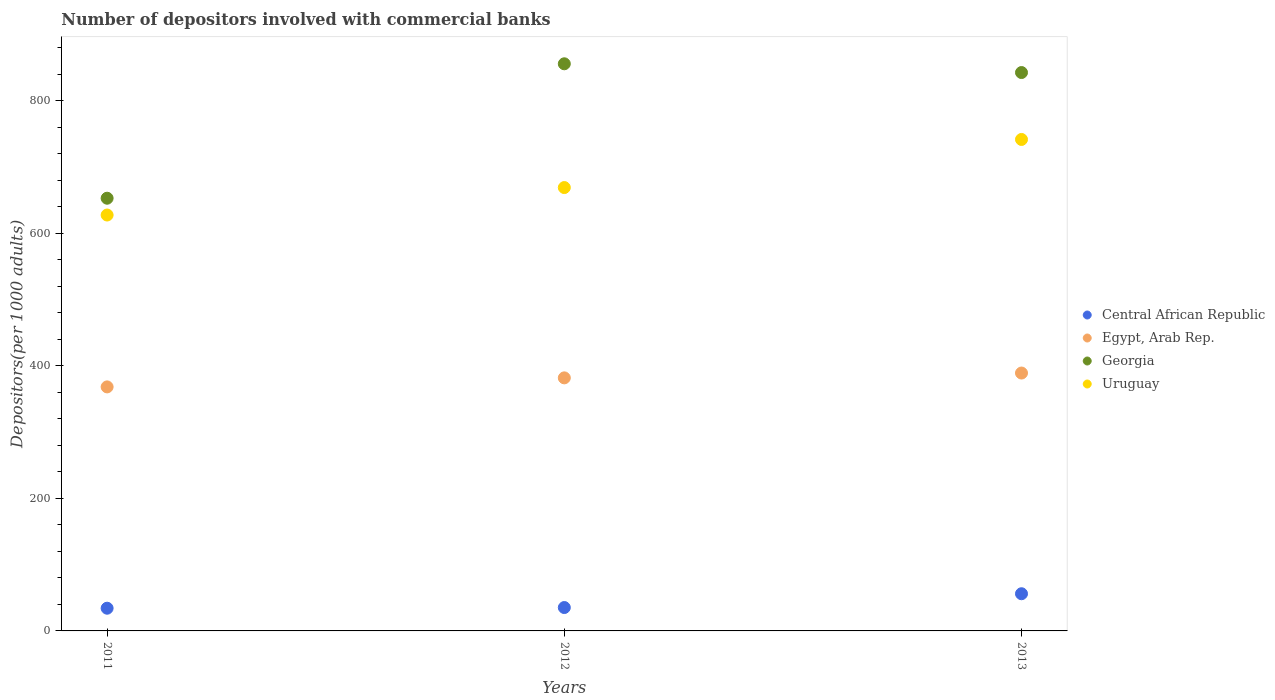How many different coloured dotlines are there?
Offer a very short reply. 4. Is the number of dotlines equal to the number of legend labels?
Your response must be concise. Yes. What is the number of depositors involved with commercial banks in Central African Republic in 2012?
Your answer should be compact. 35.28. Across all years, what is the maximum number of depositors involved with commercial banks in Central African Republic?
Make the answer very short. 56.1. Across all years, what is the minimum number of depositors involved with commercial banks in Egypt, Arab Rep.?
Offer a very short reply. 368.19. In which year was the number of depositors involved with commercial banks in Uruguay maximum?
Your response must be concise. 2013. In which year was the number of depositors involved with commercial banks in Egypt, Arab Rep. minimum?
Provide a succinct answer. 2011. What is the total number of depositors involved with commercial banks in Georgia in the graph?
Make the answer very short. 2351.11. What is the difference between the number of depositors involved with commercial banks in Central African Republic in 2012 and that in 2013?
Your answer should be very brief. -20.82. What is the difference between the number of depositors involved with commercial banks in Georgia in 2011 and the number of depositors involved with commercial banks in Uruguay in 2012?
Your answer should be very brief. -16.08. What is the average number of depositors involved with commercial banks in Uruguay per year?
Your answer should be compact. 679.35. In the year 2012, what is the difference between the number of depositors involved with commercial banks in Egypt, Arab Rep. and number of depositors involved with commercial banks in Georgia?
Offer a very short reply. -473.89. What is the ratio of the number of depositors involved with commercial banks in Uruguay in 2011 to that in 2013?
Provide a short and direct response. 0.85. Is the number of depositors involved with commercial banks in Georgia in 2011 less than that in 2013?
Ensure brevity in your answer.  Yes. Is the difference between the number of depositors involved with commercial banks in Egypt, Arab Rep. in 2011 and 2012 greater than the difference between the number of depositors involved with commercial banks in Georgia in 2011 and 2012?
Ensure brevity in your answer.  Yes. What is the difference between the highest and the second highest number of depositors involved with commercial banks in Georgia?
Your response must be concise. 13.2. What is the difference between the highest and the lowest number of depositors involved with commercial banks in Egypt, Arab Rep.?
Offer a terse response. 20.91. In how many years, is the number of depositors involved with commercial banks in Uruguay greater than the average number of depositors involved with commercial banks in Uruguay taken over all years?
Your answer should be very brief. 1. Is it the case that in every year, the sum of the number of depositors involved with commercial banks in Central African Republic and number of depositors involved with commercial banks in Egypt, Arab Rep.  is greater than the number of depositors involved with commercial banks in Uruguay?
Provide a short and direct response. No. Does the number of depositors involved with commercial banks in Central African Republic monotonically increase over the years?
Keep it short and to the point. Yes. Is the number of depositors involved with commercial banks in Egypt, Arab Rep. strictly greater than the number of depositors involved with commercial banks in Uruguay over the years?
Offer a very short reply. No. How many dotlines are there?
Offer a terse response. 4. What is the difference between two consecutive major ticks on the Y-axis?
Your response must be concise. 200. Are the values on the major ticks of Y-axis written in scientific E-notation?
Offer a terse response. No. Does the graph contain grids?
Give a very brief answer. No. Where does the legend appear in the graph?
Your answer should be very brief. Center right. How many legend labels are there?
Your answer should be very brief. 4. How are the legend labels stacked?
Make the answer very short. Vertical. What is the title of the graph?
Give a very brief answer. Number of depositors involved with commercial banks. Does "Angola" appear as one of the legend labels in the graph?
Your answer should be compact. No. What is the label or title of the Y-axis?
Offer a terse response. Depositors(per 1000 adults). What is the Depositors(per 1000 adults) in Central African Republic in 2011?
Keep it short and to the point. 34.26. What is the Depositors(per 1000 adults) in Egypt, Arab Rep. in 2011?
Offer a very short reply. 368.19. What is the Depositors(per 1000 adults) in Georgia in 2011?
Your response must be concise. 652.89. What is the Depositors(per 1000 adults) in Uruguay in 2011?
Your answer should be very brief. 627.53. What is the Depositors(per 1000 adults) in Central African Republic in 2012?
Provide a succinct answer. 35.28. What is the Depositors(per 1000 adults) in Egypt, Arab Rep. in 2012?
Offer a very short reply. 381.83. What is the Depositors(per 1000 adults) in Georgia in 2012?
Make the answer very short. 855.71. What is the Depositors(per 1000 adults) in Uruguay in 2012?
Your answer should be very brief. 668.96. What is the Depositors(per 1000 adults) of Central African Republic in 2013?
Give a very brief answer. 56.1. What is the Depositors(per 1000 adults) of Egypt, Arab Rep. in 2013?
Provide a succinct answer. 389.11. What is the Depositors(per 1000 adults) of Georgia in 2013?
Your answer should be very brief. 842.51. What is the Depositors(per 1000 adults) in Uruguay in 2013?
Provide a succinct answer. 741.55. Across all years, what is the maximum Depositors(per 1000 adults) in Central African Republic?
Give a very brief answer. 56.1. Across all years, what is the maximum Depositors(per 1000 adults) of Egypt, Arab Rep.?
Offer a very short reply. 389.11. Across all years, what is the maximum Depositors(per 1000 adults) in Georgia?
Ensure brevity in your answer.  855.71. Across all years, what is the maximum Depositors(per 1000 adults) of Uruguay?
Ensure brevity in your answer.  741.55. Across all years, what is the minimum Depositors(per 1000 adults) of Central African Republic?
Your response must be concise. 34.26. Across all years, what is the minimum Depositors(per 1000 adults) in Egypt, Arab Rep.?
Provide a short and direct response. 368.19. Across all years, what is the minimum Depositors(per 1000 adults) in Georgia?
Provide a short and direct response. 652.89. Across all years, what is the minimum Depositors(per 1000 adults) in Uruguay?
Give a very brief answer. 627.53. What is the total Depositors(per 1000 adults) of Central African Republic in the graph?
Make the answer very short. 125.63. What is the total Depositors(per 1000 adults) in Egypt, Arab Rep. in the graph?
Provide a succinct answer. 1139.13. What is the total Depositors(per 1000 adults) in Georgia in the graph?
Offer a terse response. 2351.11. What is the total Depositors(per 1000 adults) in Uruguay in the graph?
Make the answer very short. 2038.04. What is the difference between the Depositors(per 1000 adults) of Central African Republic in 2011 and that in 2012?
Offer a very short reply. -1.02. What is the difference between the Depositors(per 1000 adults) in Egypt, Arab Rep. in 2011 and that in 2012?
Your answer should be very brief. -13.63. What is the difference between the Depositors(per 1000 adults) in Georgia in 2011 and that in 2012?
Ensure brevity in your answer.  -202.83. What is the difference between the Depositors(per 1000 adults) in Uruguay in 2011 and that in 2012?
Ensure brevity in your answer.  -41.43. What is the difference between the Depositors(per 1000 adults) of Central African Republic in 2011 and that in 2013?
Provide a short and direct response. -21.84. What is the difference between the Depositors(per 1000 adults) of Egypt, Arab Rep. in 2011 and that in 2013?
Make the answer very short. -20.91. What is the difference between the Depositors(per 1000 adults) in Georgia in 2011 and that in 2013?
Your response must be concise. -189.63. What is the difference between the Depositors(per 1000 adults) of Uruguay in 2011 and that in 2013?
Your response must be concise. -114.02. What is the difference between the Depositors(per 1000 adults) of Central African Republic in 2012 and that in 2013?
Provide a succinct answer. -20.82. What is the difference between the Depositors(per 1000 adults) of Egypt, Arab Rep. in 2012 and that in 2013?
Your answer should be very brief. -7.28. What is the difference between the Depositors(per 1000 adults) of Georgia in 2012 and that in 2013?
Offer a very short reply. 13.2. What is the difference between the Depositors(per 1000 adults) in Uruguay in 2012 and that in 2013?
Your answer should be very brief. -72.59. What is the difference between the Depositors(per 1000 adults) in Central African Republic in 2011 and the Depositors(per 1000 adults) in Egypt, Arab Rep. in 2012?
Give a very brief answer. -347.57. What is the difference between the Depositors(per 1000 adults) in Central African Republic in 2011 and the Depositors(per 1000 adults) in Georgia in 2012?
Provide a succinct answer. -821.46. What is the difference between the Depositors(per 1000 adults) of Central African Republic in 2011 and the Depositors(per 1000 adults) of Uruguay in 2012?
Provide a short and direct response. -634.71. What is the difference between the Depositors(per 1000 adults) in Egypt, Arab Rep. in 2011 and the Depositors(per 1000 adults) in Georgia in 2012?
Your answer should be very brief. -487.52. What is the difference between the Depositors(per 1000 adults) of Egypt, Arab Rep. in 2011 and the Depositors(per 1000 adults) of Uruguay in 2012?
Provide a succinct answer. -300.77. What is the difference between the Depositors(per 1000 adults) in Georgia in 2011 and the Depositors(per 1000 adults) in Uruguay in 2012?
Ensure brevity in your answer.  -16.08. What is the difference between the Depositors(per 1000 adults) in Central African Republic in 2011 and the Depositors(per 1000 adults) in Egypt, Arab Rep. in 2013?
Offer a terse response. -354.85. What is the difference between the Depositors(per 1000 adults) of Central African Republic in 2011 and the Depositors(per 1000 adults) of Georgia in 2013?
Offer a very short reply. -808.26. What is the difference between the Depositors(per 1000 adults) of Central African Republic in 2011 and the Depositors(per 1000 adults) of Uruguay in 2013?
Ensure brevity in your answer.  -707.29. What is the difference between the Depositors(per 1000 adults) of Egypt, Arab Rep. in 2011 and the Depositors(per 1000 adults) of Georgia in 2013?
Your response must be concise. -474.32. What is the difference between the Depositors(per 1000 adults) in Egypt, Arab Rep. in 2011 and the Depositors(per 1000 adults) in Uruguay in 2013?
Provide a succinct answer. -373.36. What is the difference between the Depositors(per 1000 adults) in Georgia in 2011 and the Depositors(per 1000 adults) in Uruguay in 2013?
Offer a very short reply. -88.66. What is the difference between the Depositors(per 1000 adults) of Central African Republic in 2012 and the Depositors(per 1000 adults) of Egypt, Arab Rep. in 2013?
Ensure brevity in your answer.  -353.83. What is the difference between the Depositors(per 1000 adults) of Central African Republic in 2012 and the Depositors(per 1000 adults) of Georgia in 2013?
Ensure brevity in your answer.  -807.23. What is the difference between the Depositors(per 1000 adults) in Central African Republic in 2012 and the Depositors(per 1000 adults) in Uruguay in 2013?
Make the answer very short. -706.27. What is the difference between the Depositors(per 1000 adults) of Egypt, Arab Rep. in 2012 and the Depositors(per 1000 adults) of Georgia in 2013?
Give a very brief answer. -460.68. What is the difference between the Depositors(per 1000 adults) in Egypt, Arab Rep. in 2012 and the Depositors(per 1000 adults) in Uruguay in 2013?
Provide a short and direct response. -359.72. What is the difference between the Depositors(per 1000 adults) of Georgia in 2012 and the Depositors(per 1000 adults) of Uruguay in 2013?
Provide a succinct answer. 114.17. What is the average Depositors(per 1000 adults) of Central African Republic per year?
Make the answer very short. 41.88. What is the average Depositors(per 1000 adults) of Egypt, Arab Rep. per year?
Offer a terse response. 379.71. What is the average Depositors(per 1000 adults) in Georgia per year?
Offer a terse response. 783.7. What is the average Depositors(per 1000 adults) of Uruguay per year?
Ensure brevity in your answer.  679.35. In the year 2011, what is the difference between the Depositors(per 1000 adults) of Central African Republic and Depositors(per 1000 adults) of Egypt, Arab Rep.?
Your answer should be very brief. -333.94. In the year 2011, what is the difference between the Depositors(per 1000 adults) in Central African Republic and Depositors(per 1000 adults) in Georgia?
Provide a succinct answer. -618.63. In the year 2011, what is the difference between the Depositors(per 1000 adults) of Central African Republic and Depositors(per 1000 adults) of Uruguay?
Offer a very short reply. -593.28. In the year 2011, what is the difference between the Depositors(per 1000 adults) of Egypt, Arab Rep. and Depositors(per 1000 adults) of Georgia?
Make the answer very short. -284.69. In the year 2011, what is the difference between the Depositors(per 1000 adults) in Egypt, Arab Rep. and Depositors(per 1000 adults) in Uruguay?
Provide a succinct answer. -259.34. In the year 2011, what is the difference between the Depositors(per 1000 adults) in Georgia and Depositors(per 1000 adults) in Uruguay?
Offer a terse response. 25.36. In the year 2012, what is the difference between the Depositors(per 1000 adults) of Central African Republic and Depositors(per 1000 adults) of Egypt, Arab Rep.?
Your answer should be very brief. -346.55. In the year 2012, what is the difference between the Depositors(per 1000 adults) in Central African Republic and Depositors(per 1000 adults) in Georgia?
Give a very brief answer. -820.43. In the year 2012, what is the difference between the Depositors(per 1000 adults) in Central African Republic and Depositors(per 1000 adults) in Uruguay?
Provide a short and direct response. -633.68. In the year 2012, what is the difference between the Depositors(per 1000 adults) in Egypt, Arab Rep. and Depositors(per 1000 adults) in Georgia?
Provide a short and direct response. -473.89. In the year 2012, what is the difference between the Depositors(per 1000 adults) of Egypt, Arab Rep. and Depositors(per 1000 adults) of Uruguay?
Give a very brief answer. -287.13. In the year 2012, what is the difference between the Depositors(per 1000 adults) in Georgia and Depositors(per 1000 adults) in Uruguay?
Your response must be concise. 186.75. In the year 2013, what is the difference between the Depositors(per 1000 adults) of Central African Republic and Depositors(per 1000 adults) of Egypt, Arab Rep.?
Make the answer very short. -333.01. In the year 2013, what is the difference between the Depositors(per 1000 adults) in Central African Republic and Depositors(per 1000 adults) in Georgia?
Your answer should be compact. -786.41. In the year 2013, what is the difference between the Depositors(per 1000 adults) in Central African Republic and Depositors(per 1000 adults) in Uruguay?
Keep it short and to the point. -685.45. In the year 2013, what is the difference between the Depositors(per 1000 adults) of Egypt, Arab Rep. and Depositors(per 1000 adults) of Georgia?
Give a very brief answer. -453.41. In the year 2013, what is the difference between the Depositors(per 1000 adults) in Egypt, Arab Rep. and Depositors(per 1000 adults) in Uruguay?
Provide a short and direct response. -352.44. In the year 2013, what is the difference between the Depositors(per 1000 adults) of Georgia and Depositors(per 1000 adults) of Uruguay?
Provide a succinct answer. 100.96. What is the ratio of the Depositors(per 1000 adults) of Central African Republic in 2011 to that in 2012?
Provide a succinct answer. 0.97. What is the ratio of the Depositors(per 1000 adults) of Egypt, Arab Rep. in 2011 to that in 2012?
Offer a very short reply. 0.96. What is the ratio of the Depositors(per 1000 adults) of Georgia in 2011 to that in 2012?
Your answer should be compact. 0.76. What is the ratio of the Depositors(per 1000 adults) in Uruguay in 2011 to that in 2012?
Your answer should be compact. 0.94. What is the ratio of the Depositors(per 1000 adults) in Central African Republic in 2011 to that in 2013?
Your answer should be very brief. 0.61. What is the ratio of the Depositors(per 1000 adults) in Egypt, Arab Rep. in 2011 to that in 2013?
Your answer should be very brief. 0.95. What is the ratio of the Depositors(per 1000 adults) in Georgia in 2011 to that in 2013?
Your answer should be very brief. 0.77. What is the ratio of the Depositors(per 1000 adults) of Uruguay in 2011 to that in 2013?
Offer a terse response. 0.85. What is the ratio of the Depositors(per 1000 adults) of Central African Republic in 2012 to that in 2013?
Keep it short and to the point. 0.63. What is the ratio of the Depositors(per 1000 adults) in Egypt, Arab Rep. in 2012 to that in 2013?
Provide a succinct answer. 0.98. What is the ratio of the Depositors(per 1000 adults) in Georgia in 2012 to that in 2013?
Your response must be concise. 1.02. What is the ratio of the Depositors(per 1000 adults) in Uruguay in 2012 to that in 2013?
Give a very brief answer. 0.9. What is the difference between the highest and the second highest Depositors(per 1000 adults) of Central African Republic?
Ensure brevity in your answer.  20.82. What is the difference between the highest and the second highest Depositors(per 1000 adults) of Egypt, Arab Rep.?
Provide a short and direct response. 7.28. What is the difference between the highest and the second highest Depositors(per 1000 adults) of Georgia?
Make the answer very short. 13.2. What is the difference between the highest and the second highest Depositors(per 1000 adults) in Uruguay?
Your response must be concise. 72.59. What is the difference between the highest and the lowest Depositors(per 1000 adults) in Central African Republic?
Your answer should be compact. 21.84. What is the difference between the highest and the lowest Depositors(per 1000 adults) in Egypt, Arab Rep.?
Keep it short and to the point. 20.91. What is the difference between the highest and the lowest Depositors(per 1000 adults) of Georgia?
Ensure brevity in your answer.  202.83. What is the difference between the highest and the lowest Depositors(per 1000 adults) of Uruguay?
Keep it short and to the point. 114.02. 